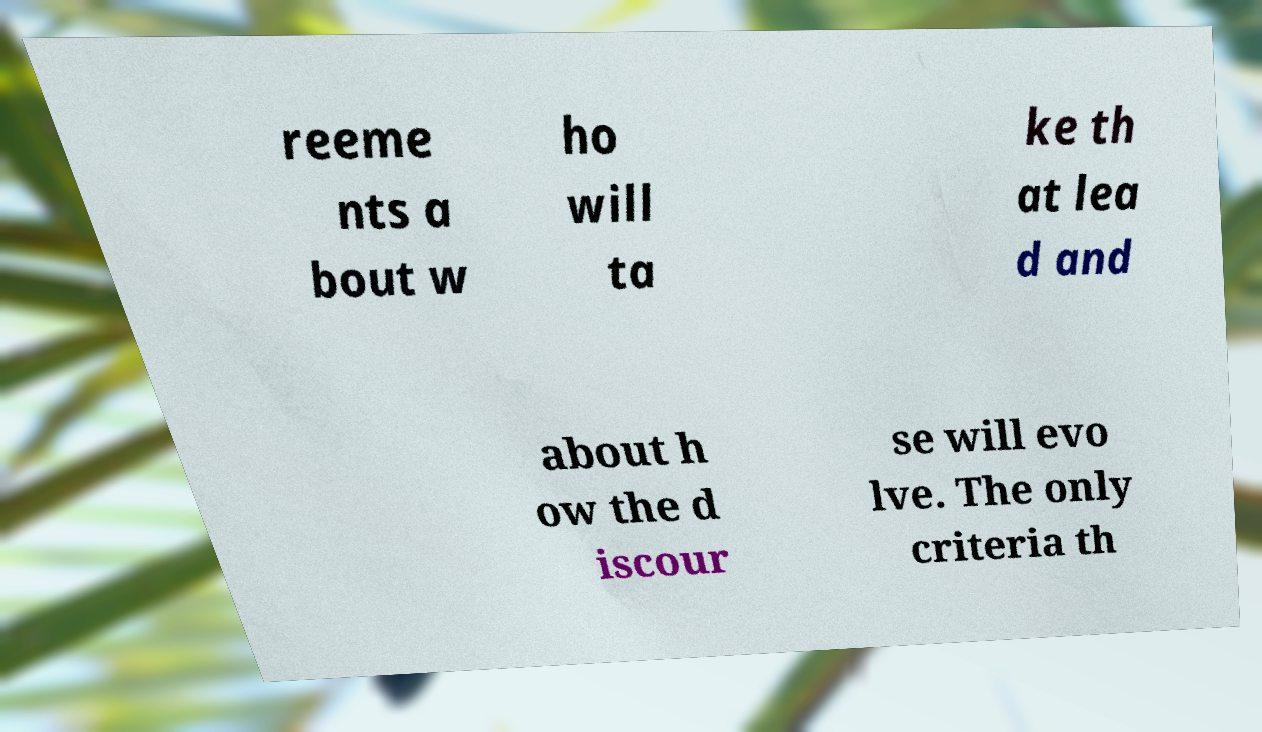There's text embedded in this image that I need extracted. Can you transcribe it verbatim? reeme nts a bout w ho will ta ke th at lea d and about h ow the d iscour se will evo lve. The only criteria th 